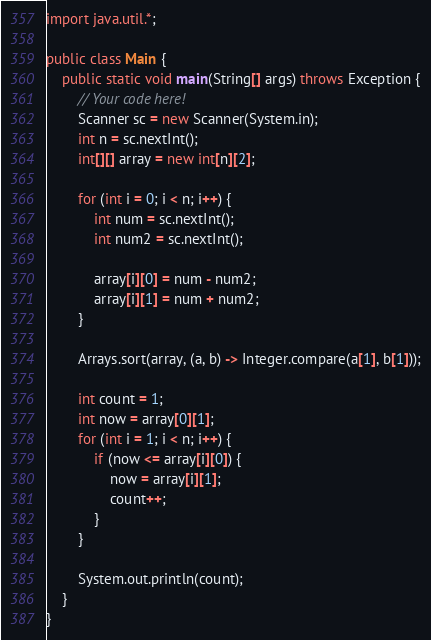<code> <loc_0><loc_0><loc_500><loc_500><_Java_>import java.util.*;

public class Main {
    public static void main(String[] args) throws Exception {
        // Your code here!
        Scanner sc = new Scanner(System.in);
        int n = sc.nextInt();
        int[][] array = new int[n][2];
        
        for (int i = 0; i < n; i++) {
            int num = sc.nextInt();
            int num2 = sc.nextInt();
            
            array[i][0] = num - num2;
            array[i][1] = num + num2;
        }
        
        Arrays.sort(array, (a, b) -> Integer.compare(a[1], b[1]));
        
        int count = 1;
        int now = array[0][1];
        for (int i = 1; i < n; i++) {
            if (now <= array[i][0]) {
                now = array[i][1];
                count++;
            }
        }
        
        System.out.println(count);
    }
}
</code> 